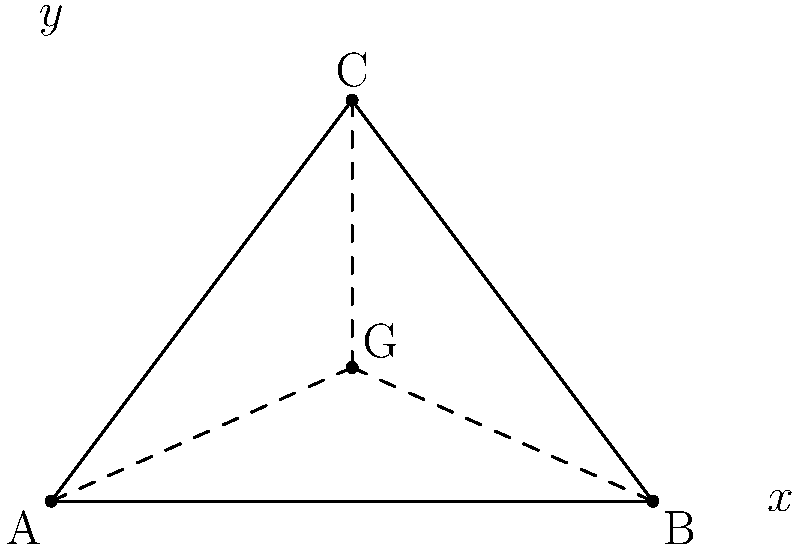In a terraced agricultural landscape, a triangular section is formed by three points: A(0,0), B(6,0), and C(3,4). Calculate the coordinates of the centroid (G) of this triangular section. To find the coordinates of the centroid of a triangle, we can follow these steps:

1. Recall that the centroid of a triangle divides each median in the ratio 2:1, with the longer segment closer to the vertex.

2. The coordinates of the centroid can be calculated using the formula:

   $G_x = \frac{x_A + x_B + x_C}{3}$ and $G_y = \frac{y_A + y_B + y_C}{3}$

   Where $(x_A, y_A)$, $(x_B, y_B)$, and $(x_C, y_C)$ are the coordinates of the triangle's vertices.

3. Given the coordinates:
   A(0,0), B(6,0), and C(3,4)

4. Calculate $G_x$:
   $G_x = \frac{0 + 6 + 3}{3} = \frac{9}{3} = 3$

5. Calculate $G_y$:
   $G_y = \frac{0 + 0 + 4}{3} = \frac{4}{3} \approx 1.33$

Therefore, the coordinates of the centroid G are (3, 4/3) or approximately (3, 1.33).
Answer: G(3, 4/3) 